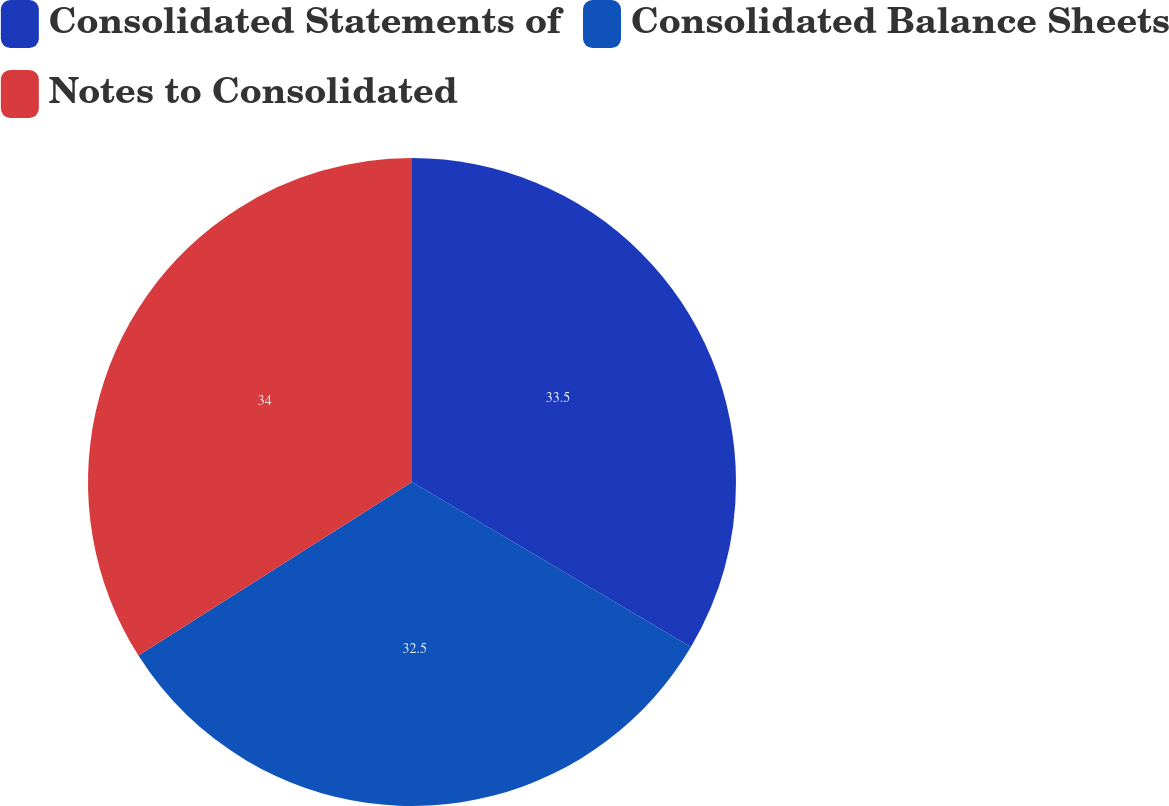Convert chart to OTSL. <chart><loc_0><loc_0><loc_500><loc_500><pie_chart><fcel>Consolidated Statements of<fcel>Consolidated Balance Sheets<fcel>Notes to Consolidated<nl><fcel>33.5%<fcel>32.5%<fcel>34.0%<nl></chart> 